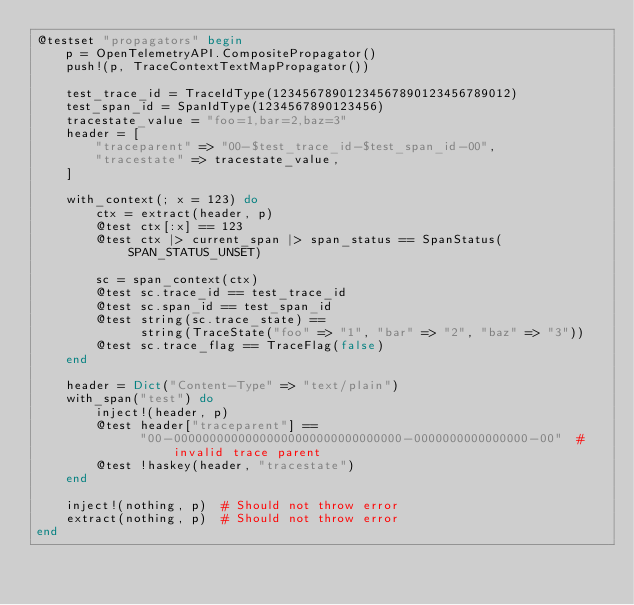Convert code to text. <code><loc_0><loc_0><loc_500><loc_500><_Julia_>@testset "propagators" begin
    p = OpenTelemetryAPI.CompositePropagator()
    push!(p, TraceContextTextMapPropagator())

    test_trace_id = TraceIdType(12345678901234567890123456789012)
    test_span_id = SpanIdType(1234567890123456)
    tracestate_value = "foo=1,bar=2,baz=3"
    header = [
        "traceparent" => "00-$test_trace_id-$test_span_id-00",
        "tracestate" => tracestate_value,
    ]

    with_context(; x = 123) do
        ctx = extract(header, p)
        @test ctx[:x] == 123
        @test ctx |> current_span |> span_status == SpanStatus(SPAN_STATUS_UNSET)

        sc = span_context(ctx)
        @test sc.trace_id == test_trace_id
        @test sc.span_id == test_span_id
        @test string(sc.trace_state) ==
              string(TraceState("foo" => "1", "bar" => "2", "baz" => "3"))
        @test sc.trace_flag == TraceFlag(false)
    end

    header = Dict("Content-Type" => "text/plain")
    with_span("test") do
        inject!(header, p)
        @test header["traceparent"] ==
              "00-00000000000000000000000000000000-0000000000000000-00"  # invalid trace parent
        @test !haskey(header, "tracestate")
    end

    inject!(nothing, p)  # Should not throw error
    extract(nothing, p)  # Should not throw error
end
</code> 